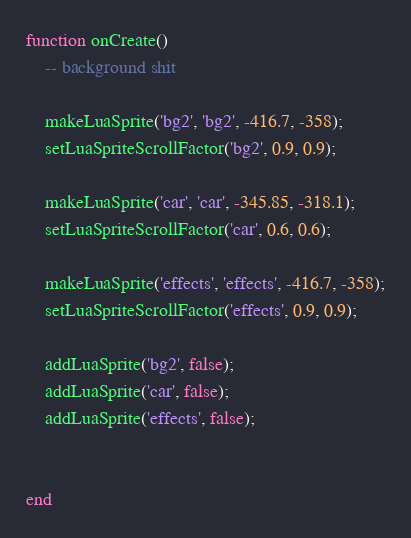<code> <loc_0><loc_0><loc_500><loc_500><_Lua_>
function onCreate()
	-- background shit

	makeLuaSprite('bg2', 'bg2', -416.7, -358);
	setLuaSpriteScrollFactor('bg2', 0.9, 0.9);

	makeLuaSprite('car', 'car', -345.85, -318.1);
	setLuaSpriteScrollFactor('car', 0.6, 0.6);

	makeLuaSprite('effects', 'effects', -416.7, -358);
	setLuaSpriteScrollFactor('effects', 0.9, 0.9);
	
	addLuaSprite('bg2', false);
	addLuaSprite('car', false);
	addLuaSprite('effects', false);

    
end</code> 